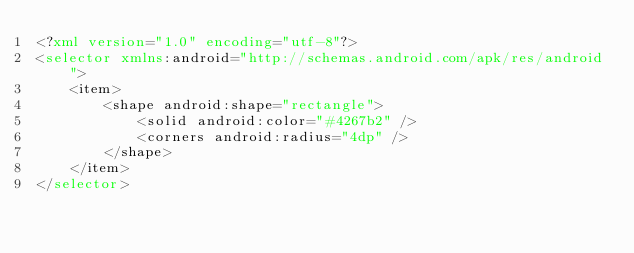Convert code to text. <code><loc_0><loc_0><loc_500><loc_500><_XML_><?xml version="1.0" encoding="utf-8"?>
<selector xmlns:android="http://schemas.android.com/apk/res/android">
    <item>
        <shape android:shape="rectangle">
            <solid android:color="#4267b2" />
            <corners android:radius="4dp" />
        </shape>
    </item>
</selector></code> 